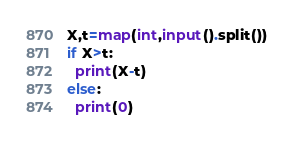Convert code to text. <code><loc_0><loc_0><loc_500><loc_500><_Python_>X,t=map(int,input().split())
if X>t:
  print(X-t)
else:
  print(0)</code> 